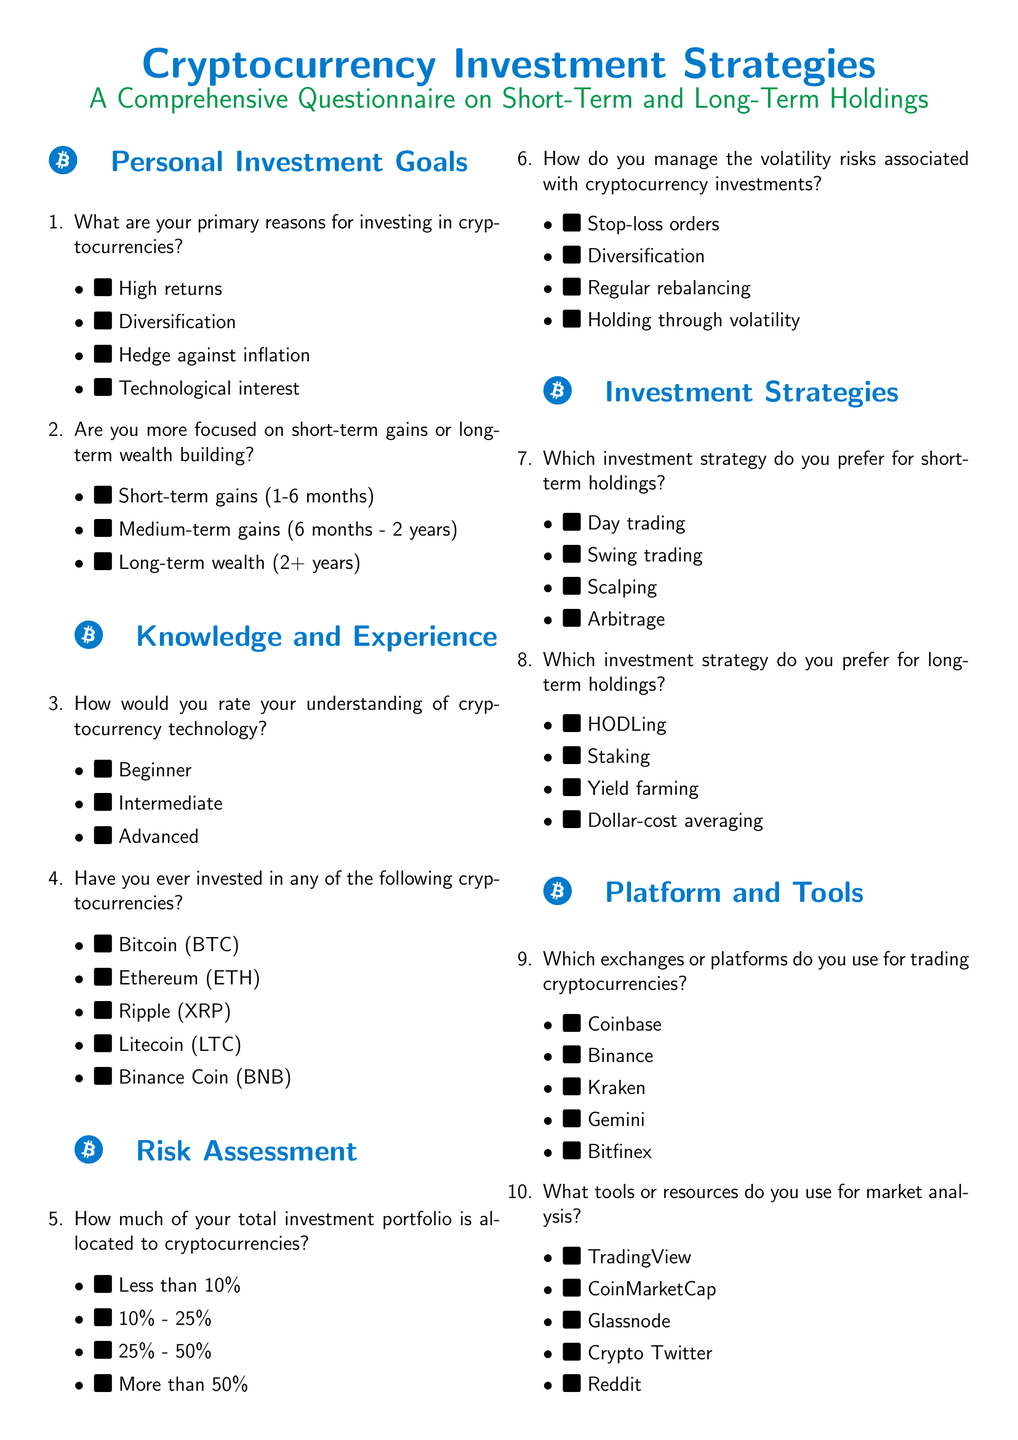What are the primary reasons for investing in cryptocurrencies? The document lists several reasons for investing in cryptocurrencies, including high returns, diversification, hedge against inflation, and technological interest.
Answer: High returns, diversification, hedge against inflation, technological interest How do you manage the volatility risks associated with cryptocurrency investments? The questionnaire provides options for managing volatility risks, such as stop-loss orders, diversification, regular rebalancing, and holding through volatility.
Answer: Stop-loss orders, diversification, regular rebalancing, holding through volatility Which investment strategy is preferred for long-term holdings? In the section regarding investment strategies, the document mentions options like HODLing, staking, yield farming, and dollar-cost averaging for long-term investments.
Answer: HODLing, staking, yield farming, dollar-cost averaging How frequently do you monitor your cryptocurrency investments? The document asks respondents about the frequency of their monitoring, with options ranging from multiple times a day to monthly.
Answer: Multiple times a day, daily, weekly, monthly How much of your total investment portfolio is allocated to cryptocurrencies? The questionnaire provides options for portfolio allocation including less than 10%, 10% - 25%, 25% - 50%, and more than 50%.
Answer: Less than 10%, 10% - 25%, 25% - 50%, more than 50% 